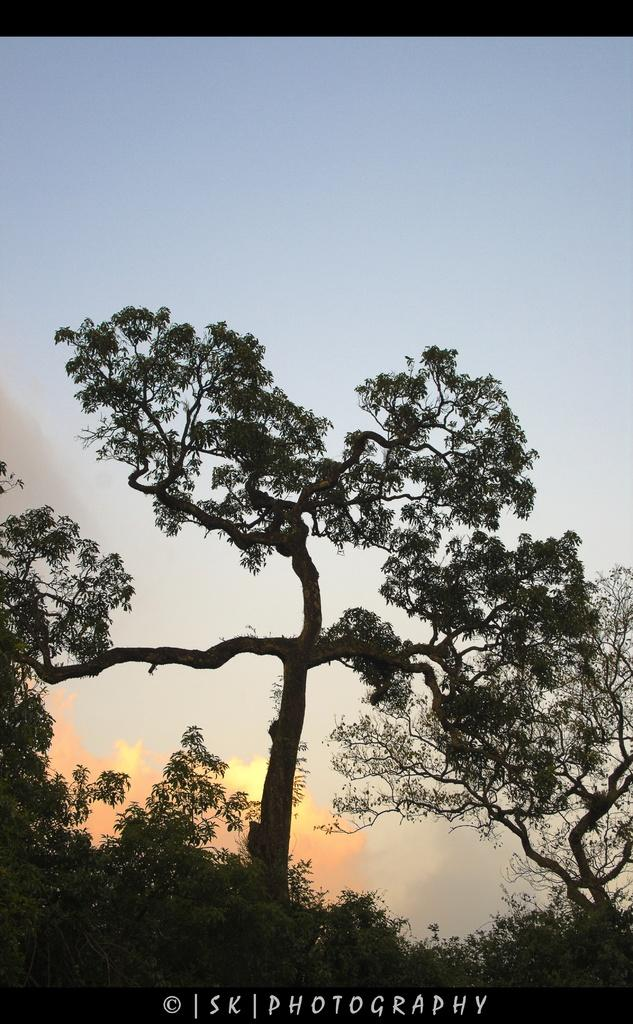What type of vegetation can be seen in the image? There are trees in the image. What part of the natural environment is visible in the image? The sky is visible in the background of the image. What type of lettuce is being used as a route for the ants in the image? There is no lettuce or ants present in the image. 